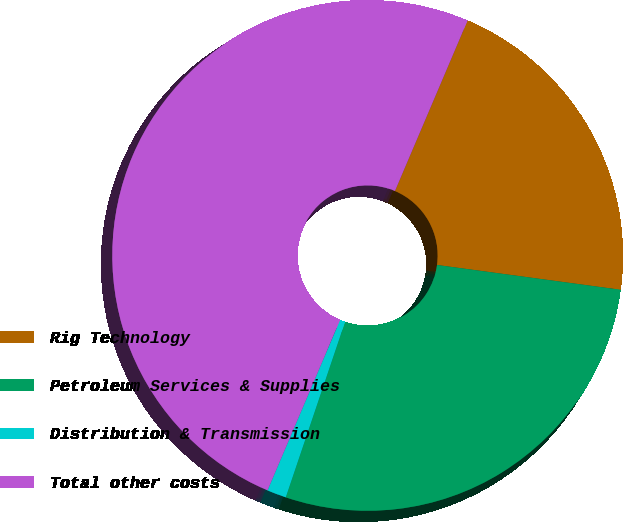Convert chart. <chart><loc_0><loc_0><loc_500><loc_500><pie_chart><fcel>Rig Technology<fcel>Petroleum Services & Supplies<fcel>Distribution & Transmission<fcel>Total other costs<nl><fcel>20.73%<fcel>28.05%<fcel>1.22%<fcel>50.0%<nl></chart> 